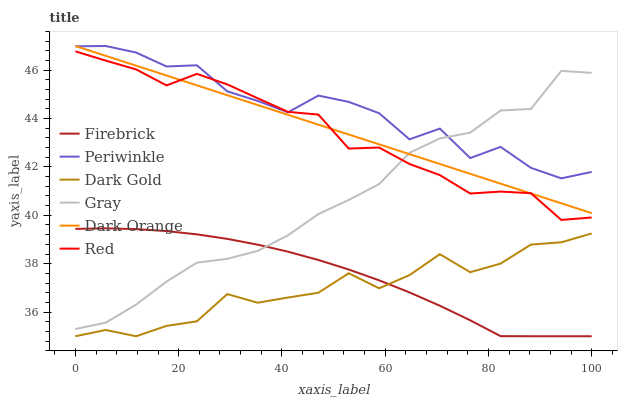Does Dark Gold have the minimum area under the curve?
Answer yes or no. Yes. Does Periwinkle have the maximum area under the curve?
Answer yes or no. Yes. Does Gray have the minimum area under the curve?
Answer yes or no. No. Does Gray have the maximum area under the curve?
Answer yes or no. No. Is Dark Orange the smoothest?
Answer yes or no. Yes. Is Periwinkle the roughest?
Answer yes or no. Yes. Is Gray the smoothest?
Answer yes or no. No. Is Gray the roughest?
Answer yes or no. No. Does Firebrick have the lowest value?
Answer yes or no. Yes. Does Gray have the lowest value?
Answer yes or no. No. Does Periwinkle have the highest value?
Answer yes or no. Yes. Does Gray have the highest value?
Answer yes or no. No. Is Dark Gold less than Periwinkle?
Answer yes or no. Yes. Is Periwinkle greater than Firebrick?
Answer yes or no. Yes. Does Red intersect Periwinkle?
Answer yes or no. Yes. Is Red less than Periwinkle?
Answer yes or no. No. Is Red greater than Periwinkle?
Answer yes or no. No. Does Dark Gold intersect Periwinkle?
Answer yes or no. No. 